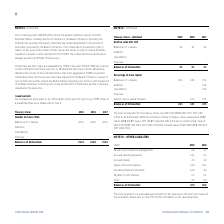According to Torm's financial document, Why is the carrying amount a reasonable approximation of fair value? due to the short-term nature of the receivables.. The document states: "amount is a reasonable approximation of fair value due to the short-term nature of the receivables. Please refer to note 21 for further information on..." Also, What information does note 21 contain? further information on fair value hierarchies.. The document states: "re of the receivables. Please refer to note 21 for further information on fair value hierarchies...." Also, In which years were the amounts of Other Liabilities calculated for? The document shows two values: 2019 and 2018. From the document: "USDm 2019 2018 USDm 2019 2018..." Additionally, In which year was the amount under Partners and commercial managements larger? According to the financial document, 2018. The relevant text states: "USDm 2019 2018..." Also, can you calculate: What was the change in the Balance as of 31 December from 2018 to 2019? Based on the calculation: 47.3-36.5, the result is 10.8 (in millions). This is based on the information: "Balance as of 31 December 47.3 36.5 Balance as of 31 December 47.3 36.5..." The key data points involved are: 36.5, 47.3. Also, can you calculate: What was the percentage change in the Balance as of 31 December from 2018 to 2019? To answer this question, I need to perform calculations using the financial data. The calculation is: (47.3-36.5)/36.5, which equals 29.59 (percentage). This is based on the information: "Balance as of 31 December 47.3 36.5 Balance as of 31 December 47.3 36.5..." The key data points involved are: 36.5, 47.3. 